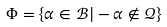<formula> <loc_0><loc_0><loc_500><loc_500>\Phi = \{ \alpha \in \mathcal { B } | - \alpha \notin \mathcal { Q } \}</formula> 